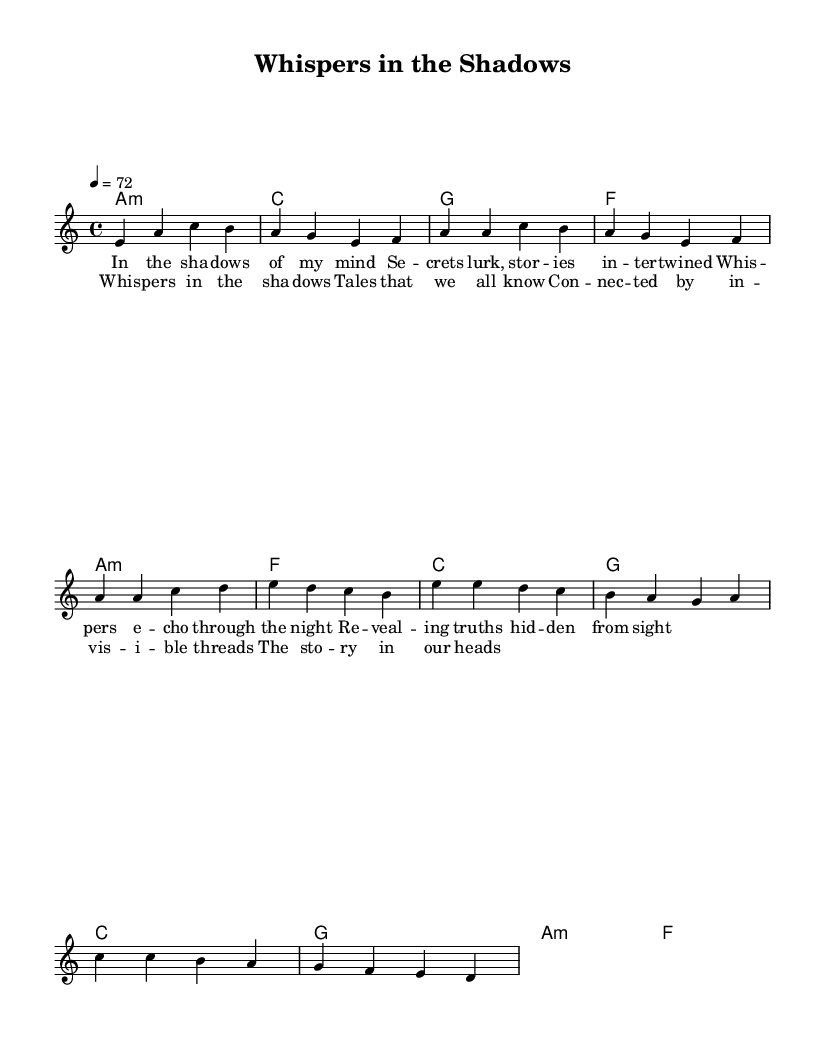What is the key signature of this music? The key signature indicated by the notation is A minor, which has no sharps or flats. A minor is the relative minor of C major, and it is visually represented by the lack of any accidentals in the clef area.
Answer: A minor What is the time signature of this music? The time signature shown in the sheet music is 4/4, which means there are four beats in each measure and the quarter note gets one beat. This is typically indicated at the beginning of the score and remains consistent throughout the piece.
Answer: 4/4 What is the tempo marking for this piece? The tempo marking is indicated as a quarter note equals 72 beats per minute, signifying a moderate pace for the performance of the music. This information is typically notated at the start of the piece, under the title.
Answer: 72 How many measures are in the chorus section? The chorus consists of four distinct measures as observed in the sheet music layout. Each measure is separated by vertical lines, and by counting these lines in the chorus section, we can determine the total number of measures.
Answer: 4 What type of album does this sheet music suggest? The sheet intimates the structure of a concept album, which is characterized by its narrative and interconnected songs. The lyrics and musical themes revolve around stories intertwined, typical of Rhythm and Blues concept albums.
Answer: Concept album Is there a repeated lyrical phrase in the piece? Yes, the chorus features the repeated phrase "whispers in the shadows," indicating a thematic continuity and reinforcing the song's central idea. The repetition is a common feature in R&B songs to emphasize the emotional connection.
Answer: Yes 